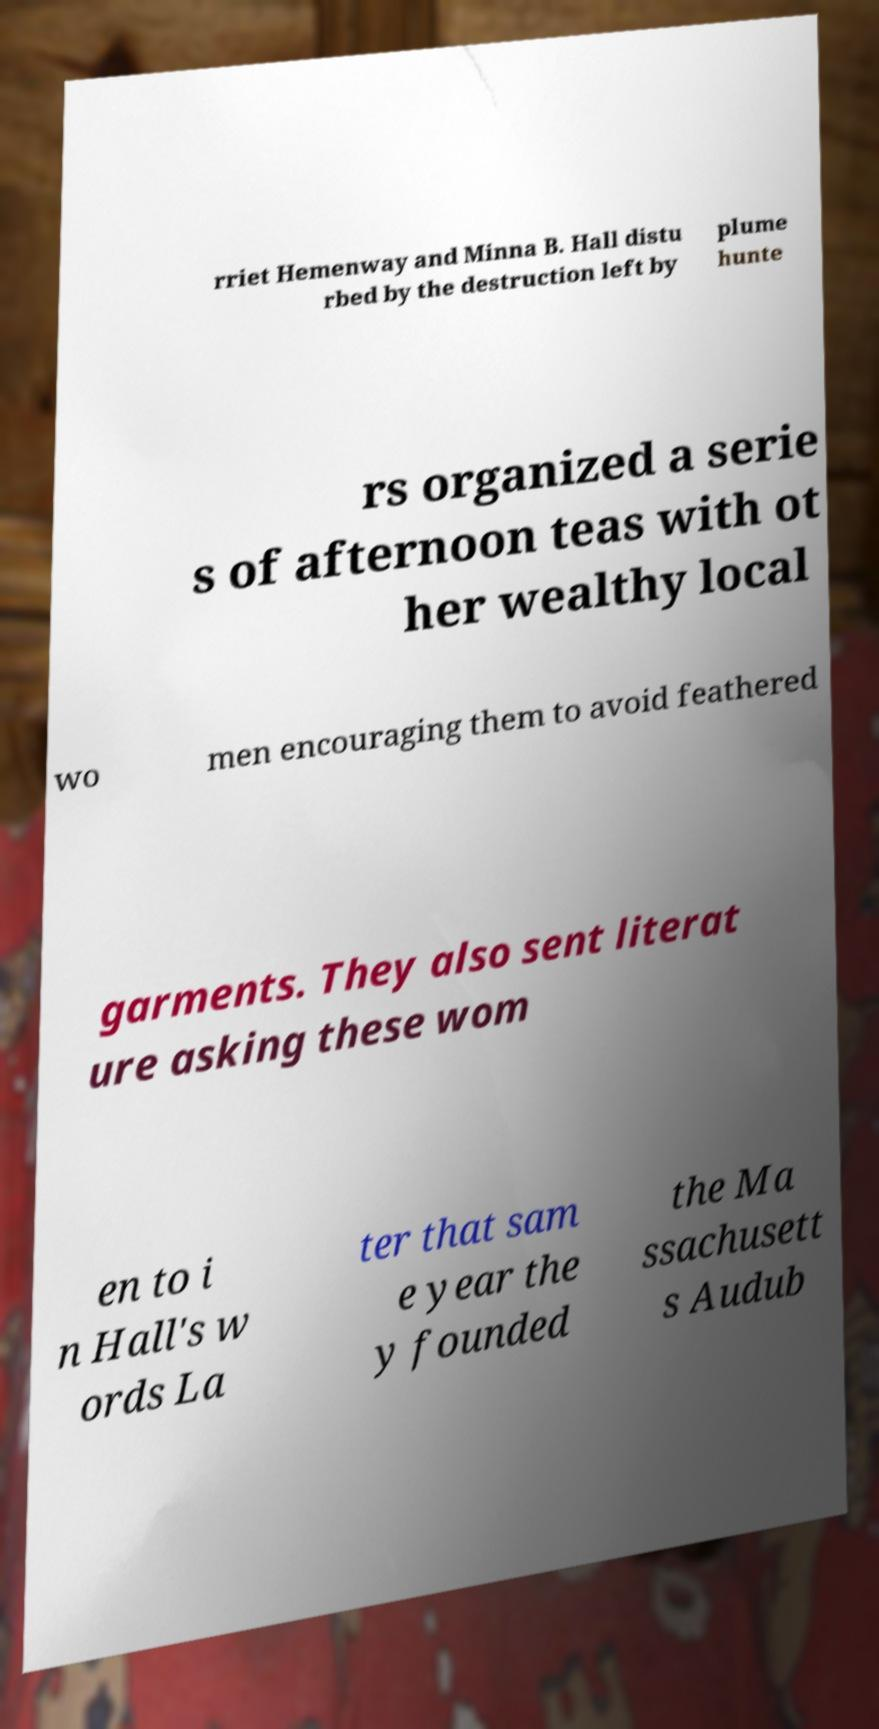Please identify and transcribe the text found in this image. rriet Hemenway and Minna B. Hall distu rbed by the destruction left by plume hunte rs organized a serie s of afternoon teas with ot her wealthy local wo men encouraging them to avoid feathered garments. They also sent literat ure asking these wom en to i n Hall's w ords La ter that sam e year the y founded the Ma ssachusett s Audub 